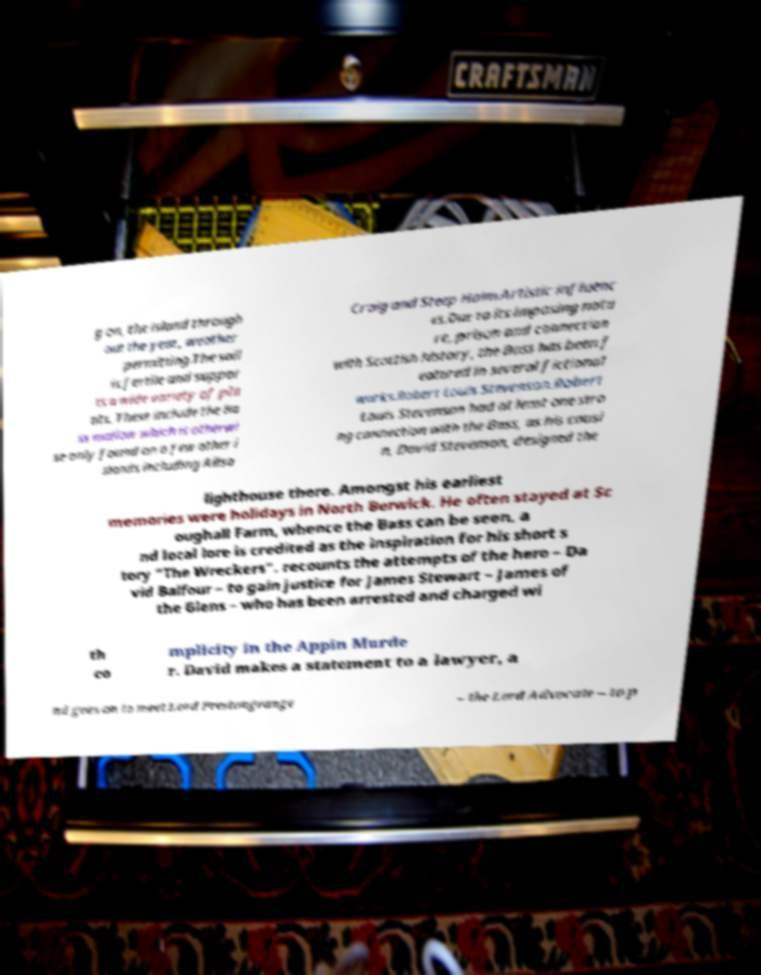I need the written content from this picture converted into text. Can you do that? g on, the island through out the year, weather permitting.The soil is fertile and suppor ts a wide variety of pla nts. These include the Ba ss mallow which is otherwi se only found on a few other i slands including Ailsa Craig and Steep Holm.Artistic influenc es.Due to its imposing natu re, prison and connection with Scottish history, the Bass has been f eatured in several fictional works.Robert Louis Stevenson.Robert Louis Stevenson had at least one stro ng connection with the Bass, as his cousi n, David Stevenson, designed the lighthouse there. Amongst his earliest memories were holidays in North Berwick. He often stayed at Sc oughall Farm, whence the Bass can be seen, a nd local lore is credited as the inspiration for his short s tory "The Wreckers". recounts the attempts of the hero – Da vid Balfour – to gain justice for James Stewart – James of the Glens – who has been arrested and charged wi th co mplicity in the Appin Murde r. David makes a statement to a lawyer, a nd goes on to meet Lord Prestongrange – the Lord Advocate – to p 